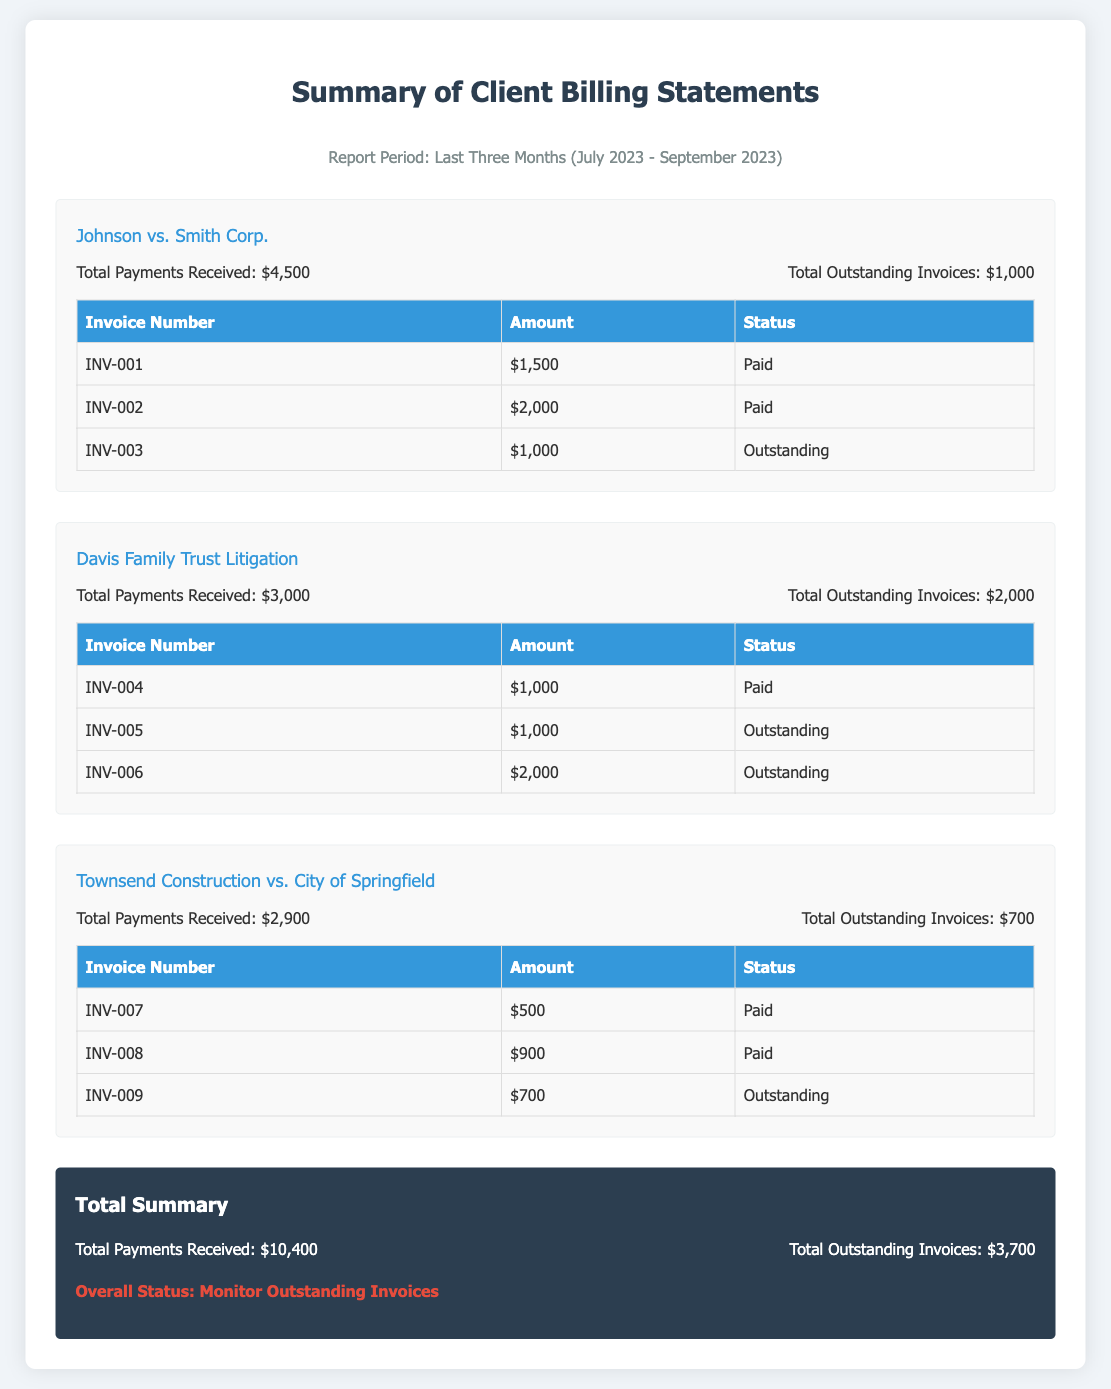What is the total payments received for Johnson vs. Smith Corp.? The document states that the total payments received for this case is $4,500.
Answer: $4,500 How many outstanding invoices are there for Davis Family Trust Litigation? The document shows that there are $2,000 in total outstanding invoices for this case, which includes two invoices listed as outstanding.
Answer: $2,000 What is the invoice number for the outstanding amount in Townsend Construction vs. City of Springfield? The document indicates that the outstanding invoice is INV-009 for this case.
Answer: INV-009 What is the overall status as mentioned in the report? The report specifies the overall status as "Monitor Outstanding Invoices."
Answer: Monitor Outstanding Invoices How much total payments were received across all cases? The document sums up the total payments received across all cases, which is $10,400.
Answer: $10,400 Which case has the highest total outstanding invoices? The document reveals that Davis Family Trust Litigation has the highest total outstanding invoices at $2,000.
Answer: Davis Family Trust Litigation What is the total number of invoices listed in the Johnson vs. Smith Corp. case? The document lists three invoices under this case, including one outstanding.
Answer: 3 What is the amount of the paid invoice marked as INV-004? The document specifies that INV-004 has an amount of $1,000 and is paid.
Answer: $1,000 What is the period covered in this financial report? The report period is indicated as the last three months, specifically from July 2023 to September 2023.
Answer: July 2023 - September 2023 